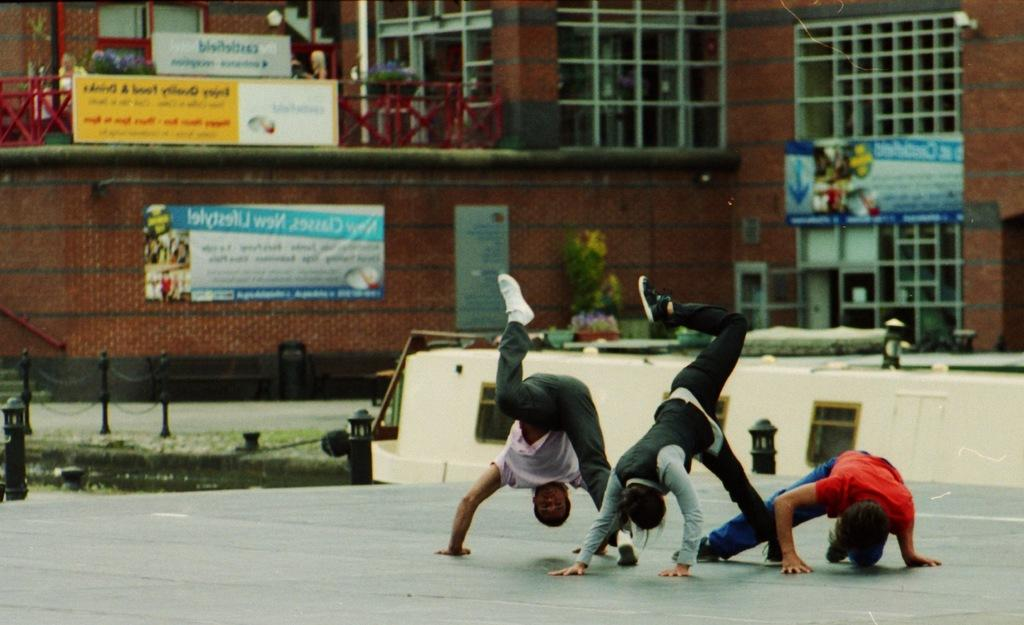What is happening with the people in the image? There are people on the ground in the image. What can be seen in the distance behind the people? There is a building visible in the background of the image. What else is present in the background of the image? There are posters present in the background of the image. What type of book is being read by the rock in the image? There is no book or rock present in the image. 